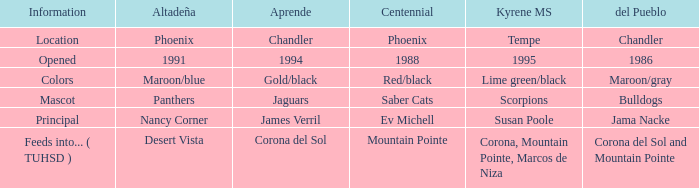Which Centennial has a Altadeña of panthers? Saber Cats. 